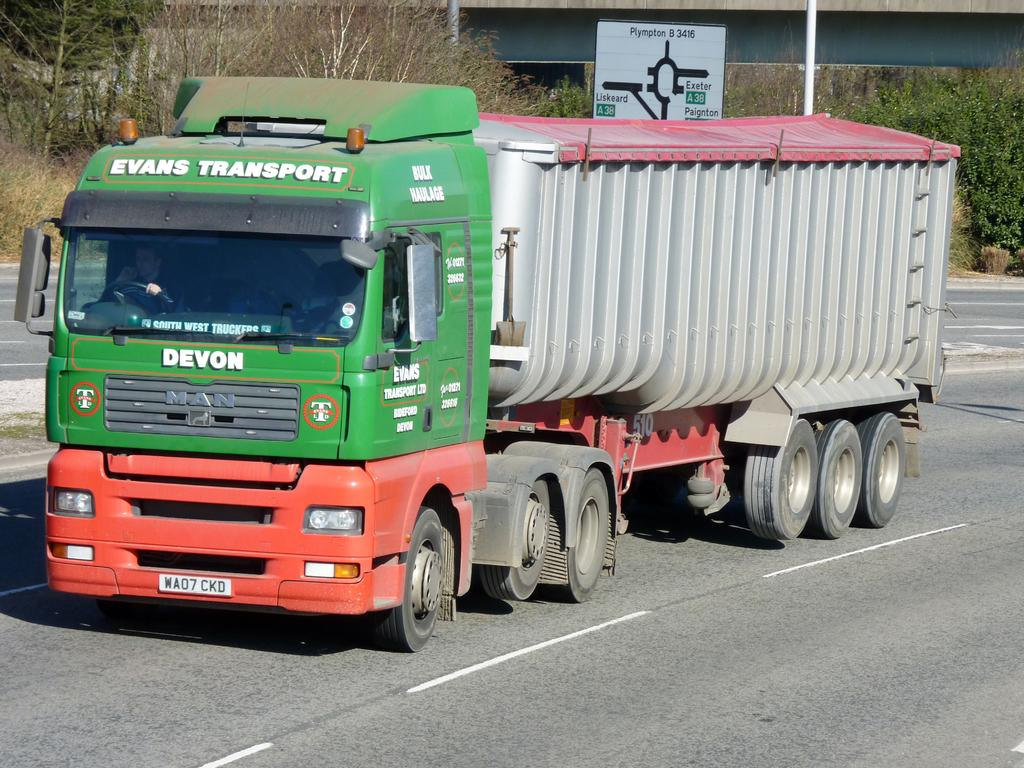What is the main subject in the foreground of the image? There is a container truck in the foreground of the image. Where is the container truck located? The container truck is on the road. What can be seen in the background of the image? There is a flyover and trees visible in the background of the image. Can you describe any other structures or objects in the image? There is a sign board pole at the top of the image. What type of oatmeal is being served to the secretary in the image? There is no secretary or oatmeal present in the image. How many slaves can be seen working on the container truck in the image? There are no slaves or any indication of labor in the image; it simply shows a container truck on the road. 